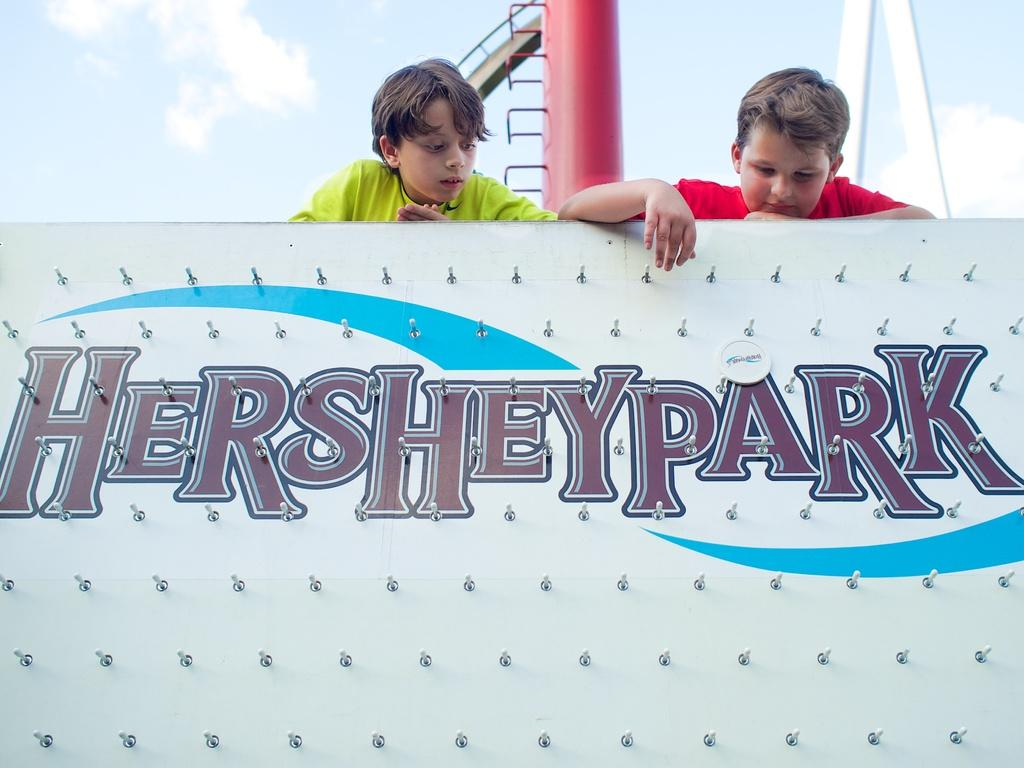What is on the board that the boys are looking at in the image? There is a board with text in the image. How many boys are looking at the board in the image? There are two boys looking at the board in the image. What can be seen in the background of the image? There are objects in the background of the image. What is visible in the sky in the image? The sky is visible in the image, and clouds are present. What type of force is being applied to the boys in the image? There is no force being applied to the boys in the image; they are simply looking at the board. 